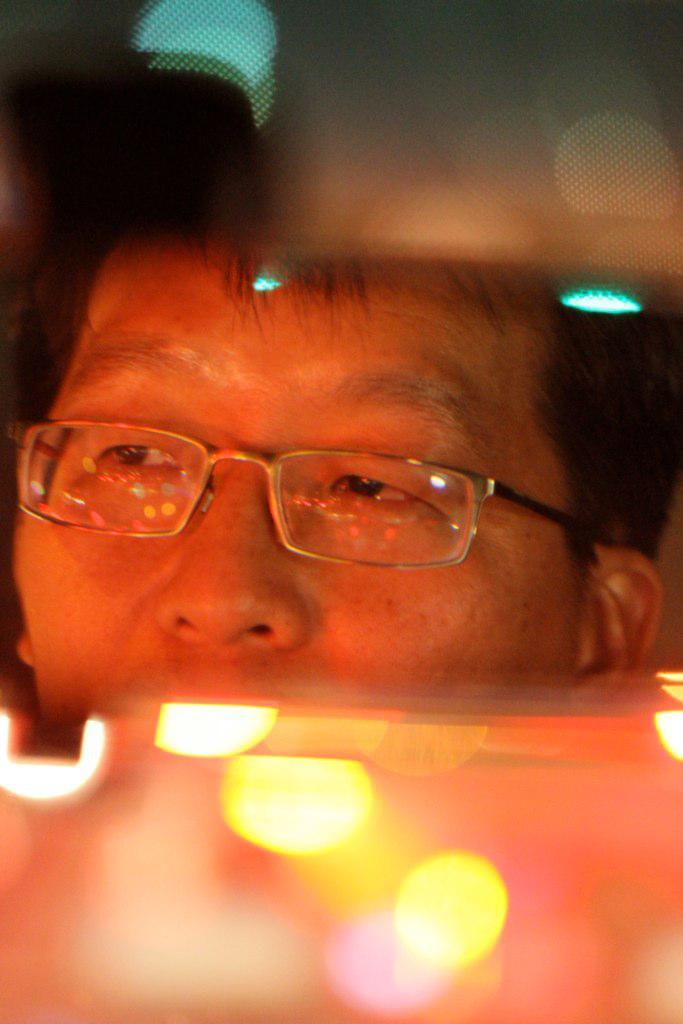Can you describe this image briefly? At the bottom the image is blur but we can see lights and at the top the image is blur. In the middle we can see a person's face reflection on a mirror. 